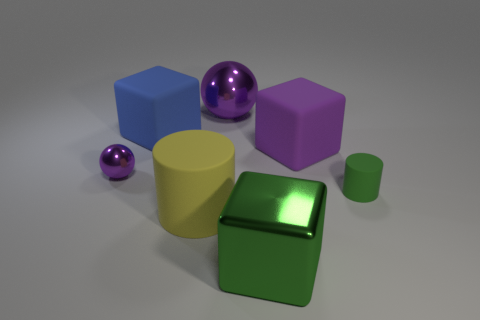Add 1 big blue matte things. How many objects exist? 8 Subtract all cubes. How many objects are left? 4 Add 3 large balls. How many large balls are left? 4 Add 7 big blue things. How many big blue things exist? 8 Subtract 1 blue cubes. How many objects are left? 6 Subtract all tiny red metal blocks. Subtract all large yellow matte things. How many objects are left? 6 